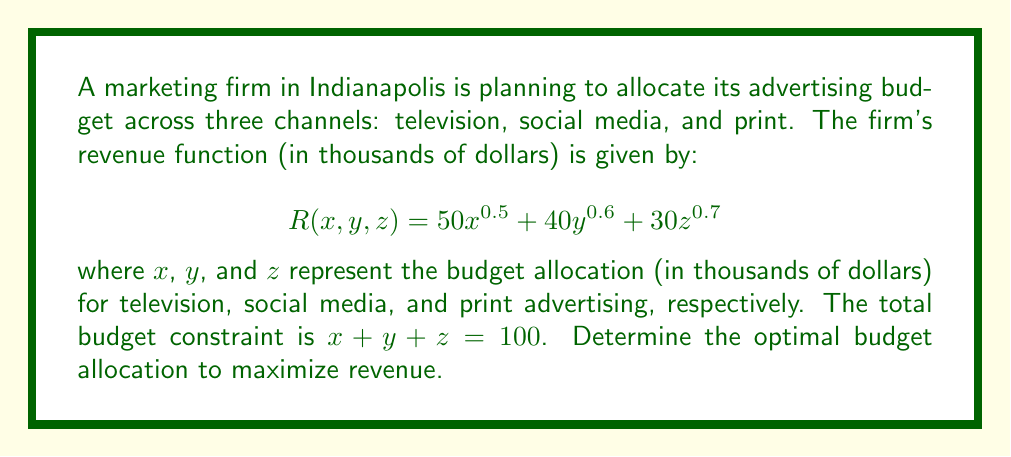Can you solve this math problem? To solve this optimization problem with a constraint, we'll use the method of Lagrange multipliers.

1) First, we form the Lagrangian function:
   $$L(x, y, z, \lambda) = 50x^{0.5} + 40y^{0.6} + 30z^{0.7} + \lambda(100 - x - y - z)$$

2) Now, we take partial derivatives and set them equal to zero:

   $$\frac{\partial L}{\partial x} = 25x^{-0.5} - \lambda = 0$$
   $$\frac{\partial L}{\partial y} = 24y^{-0.4} - \lambda = 0$$
   $$\frac{\partial L}{\partial z} = 21z^{-0.3} - \lambda = 0$$
   $$\frac{\partial L}{\partial \lambda} = 100 - x - y - z = 0$$

3) From the first three equations:
   $$x = (\frac{25}{\lambda})^2$$
   $$y = (\frac{24}{\lambda})^{2.5}$$
   $$z = (\frac{21}{\lambda})^{3.33333}$$

4) Substituting these into the constraint equation:
   $$(\frac{25}{\lambda})^2 + (\frac{24}{\lambda})^{2.5} + (\frac{21}{\lambda})^{3.33333} = 100$$

5) This equation can be solved numerically to find $\lambda \approx 4.1645$

6) Substituting this value back into the equations from step 3:
   $$x \approx 36.0$$
   $$y \approx 33.7$$
   $$z \approx 30.3$$

7) We can verify that these sum to 100 (within rounding error) and that this is indeed a maximum by checking the second derivative test (omitted for brevity).
Answer: The optimal budget allocation to maximize revenue is approximately:
Television (x): $36,000
Social Media (y): $33,700
Print (z): $30,300 